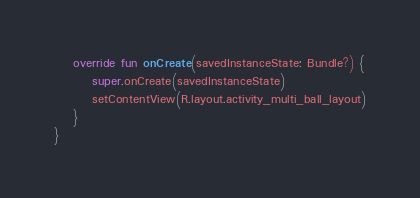Convert code to text. <code><loc_0><loc_0><loc_500><loc_500><_Kotlin_>
    override fun onCreate(savedInstanceState: Bundle?) {
        super.onCreate(savedInstanceState)
        setContentView(R.layout.activity_multi_ball_layout)
    }
}</code> 